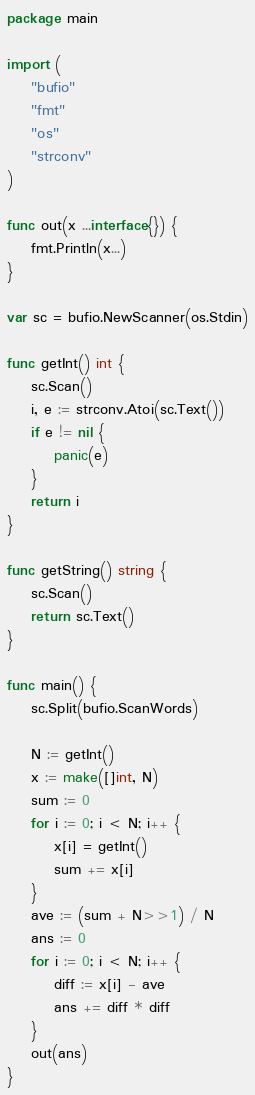<code> <loc_0><loc_0><loc_500><loc_500><_Go_>package main

import (
	"bufio"
	"fmt"
	"os"
	"strconv"
)

func out(x ...interface{}) {
	fmt.Println(x...)
}

var sc = bufio.NewScanner(os.Stdin)

func getInt() int {
	sc.Scan()
	i, e := strconv.Atoi(sc.Text())
	if e != nil {
		panic(e)
	}
	return i
}

func getString() string {
	sc.Scan()
	return sc.Text()
}

func main() {
	sc.Split(bufio.ScanWords)

	N := getInt()
	x := make([]int, N)
	sum := 0
	for i := 0; i < N; i++ {
		x[i] = getInt()
		sum += x[i]
	}
	ave := (sum + N>>1) / N
	ans := 0
	for i := 0; i < N; i++ {
		diff := x[i] - ave
		ans += diff * diff
	}
	out(ans)
}
</code> 